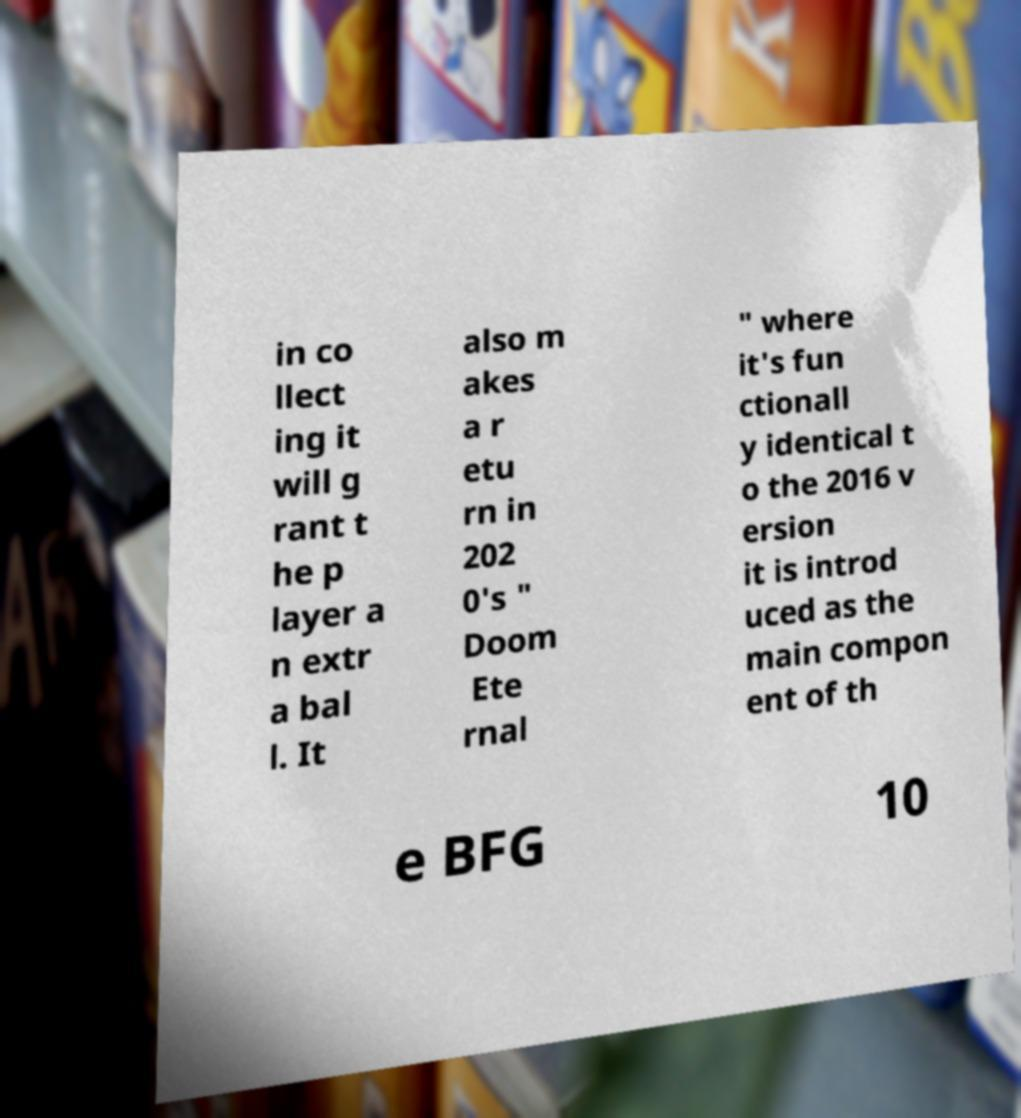What messages or text are displayed in this image? I need them in a readable, typed format. in co llect ing it will g rant t he p layer a n extr a bal l. It also m akes a r etu rn in 202 0's " Doom Ete rnal " where it's fun ctionall y identical t o the 2016 v ersion it is introd uced as the main compon ent of th e BFG 10 